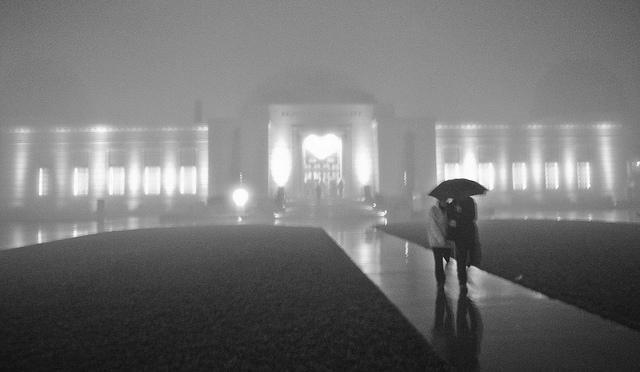What time of day is it? Please explain your reasoning. dusk. The lights are on because it is dark outside. 